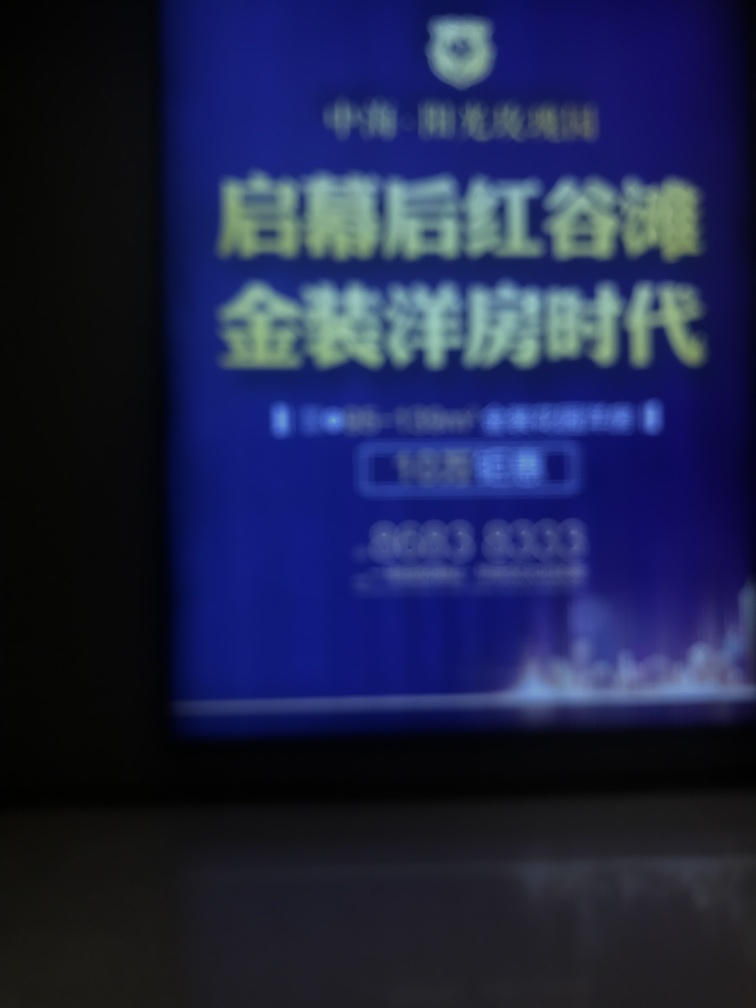What might be the reason for the image being blurry? The blurriness can result from several factors, such as camera shake, incorrect focus settings, or movement of the subject during the exposure time. 